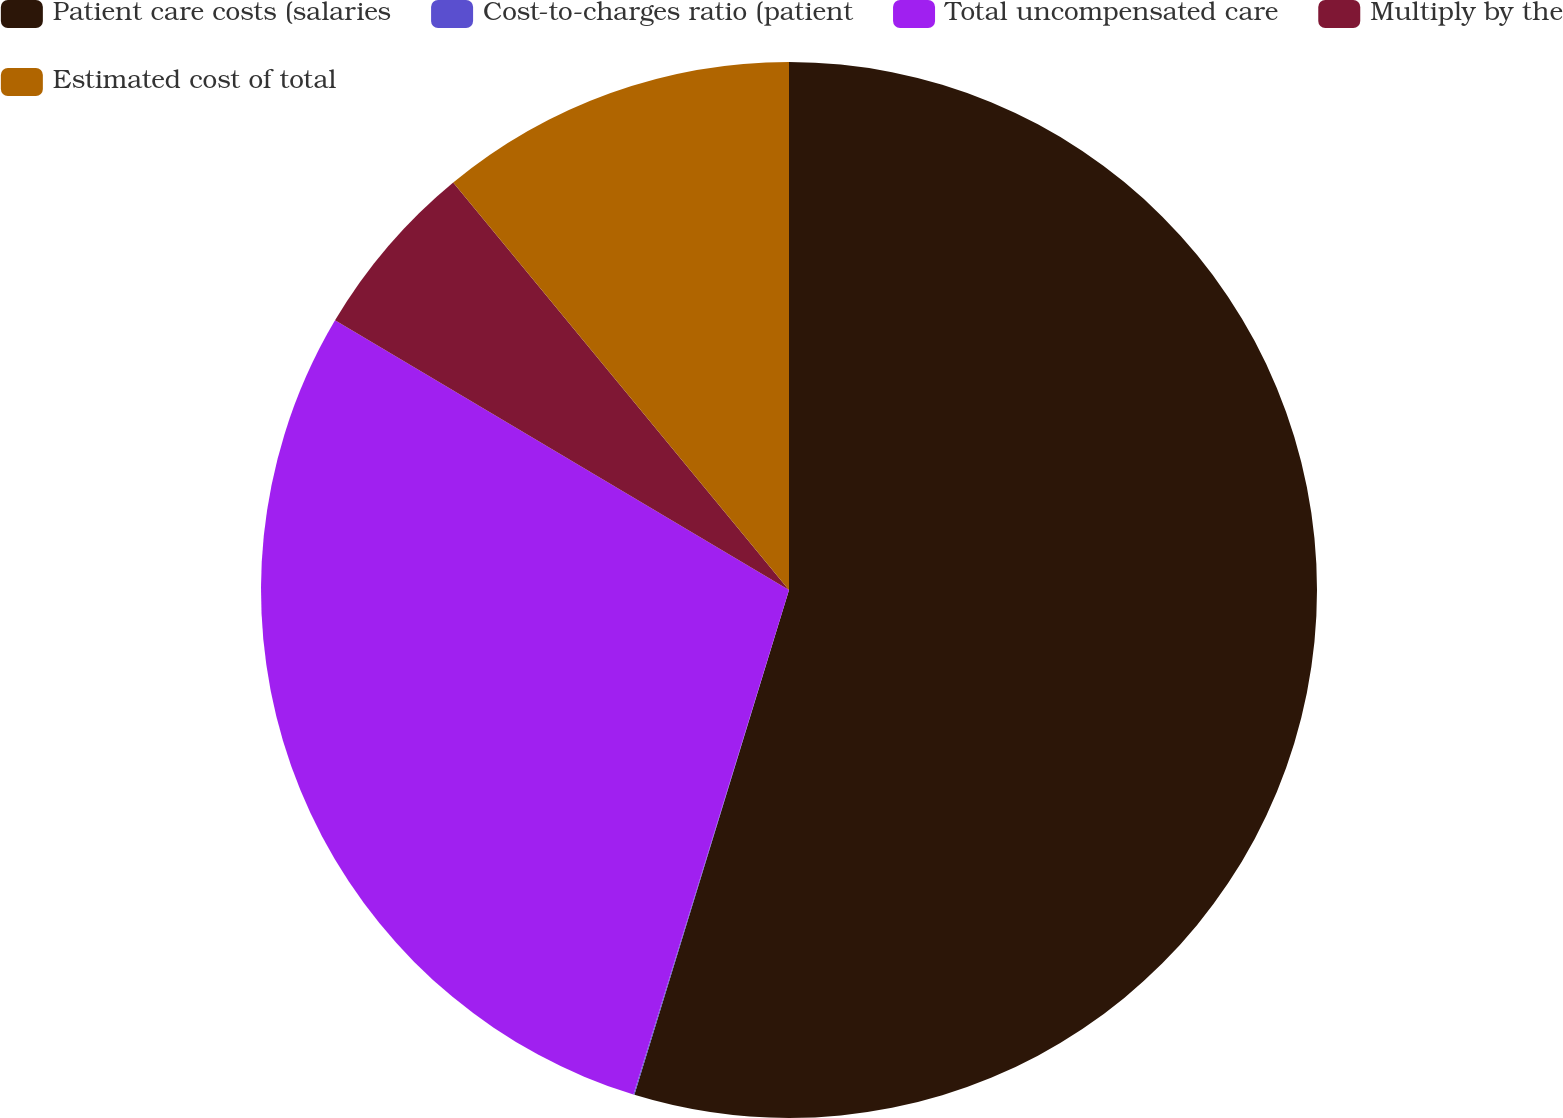Convert chart to OTSL. <chart><loc_0><loc_0><loc_500><loc_500><pie_chart><fcel>Patient care costs (salaries<fcel>Cost-to-charges ratio (patient<fcel>Total uncompensated care<fcel>Multiply by the<fcel>Estimated cost of total<nl><fcel>54.73%<fcel>0.03%<fcel>28.77%<fcel>5.5%<fcel>10.97%<nl></chart> 